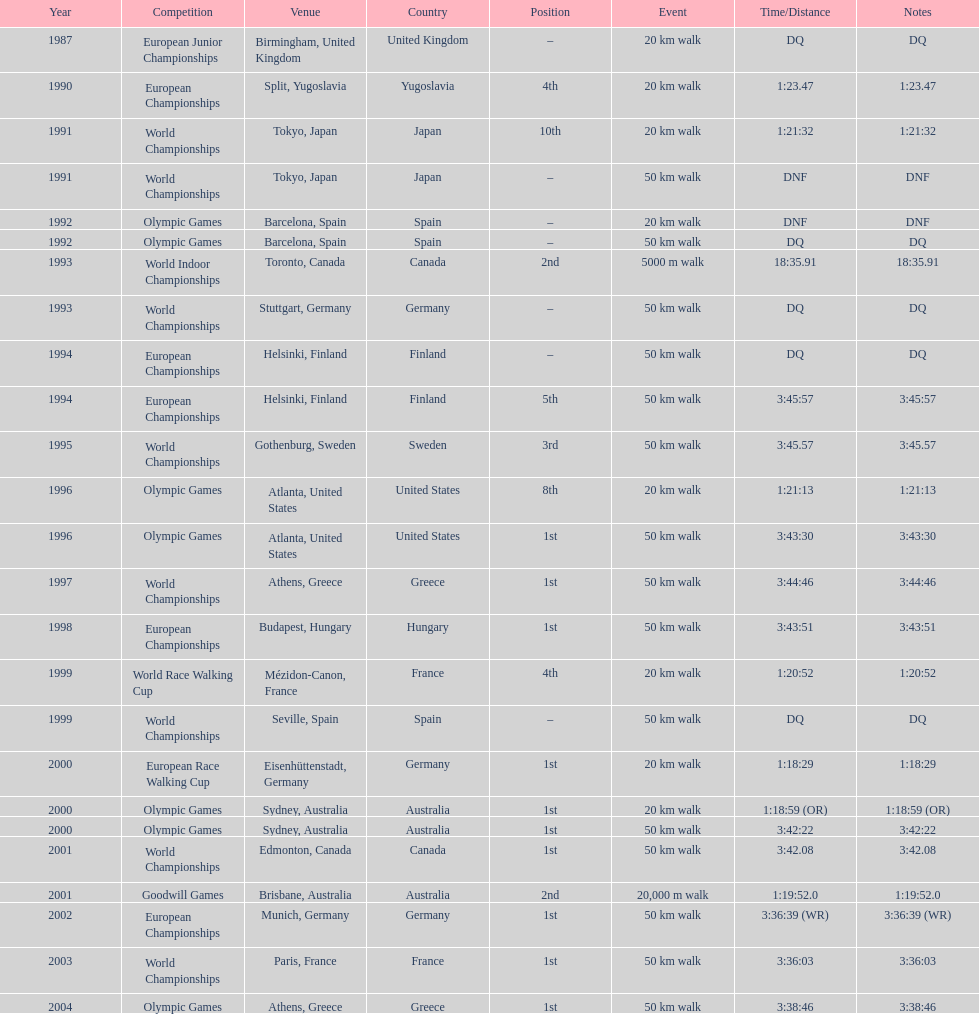How many times was first place listed as the position? 10. 